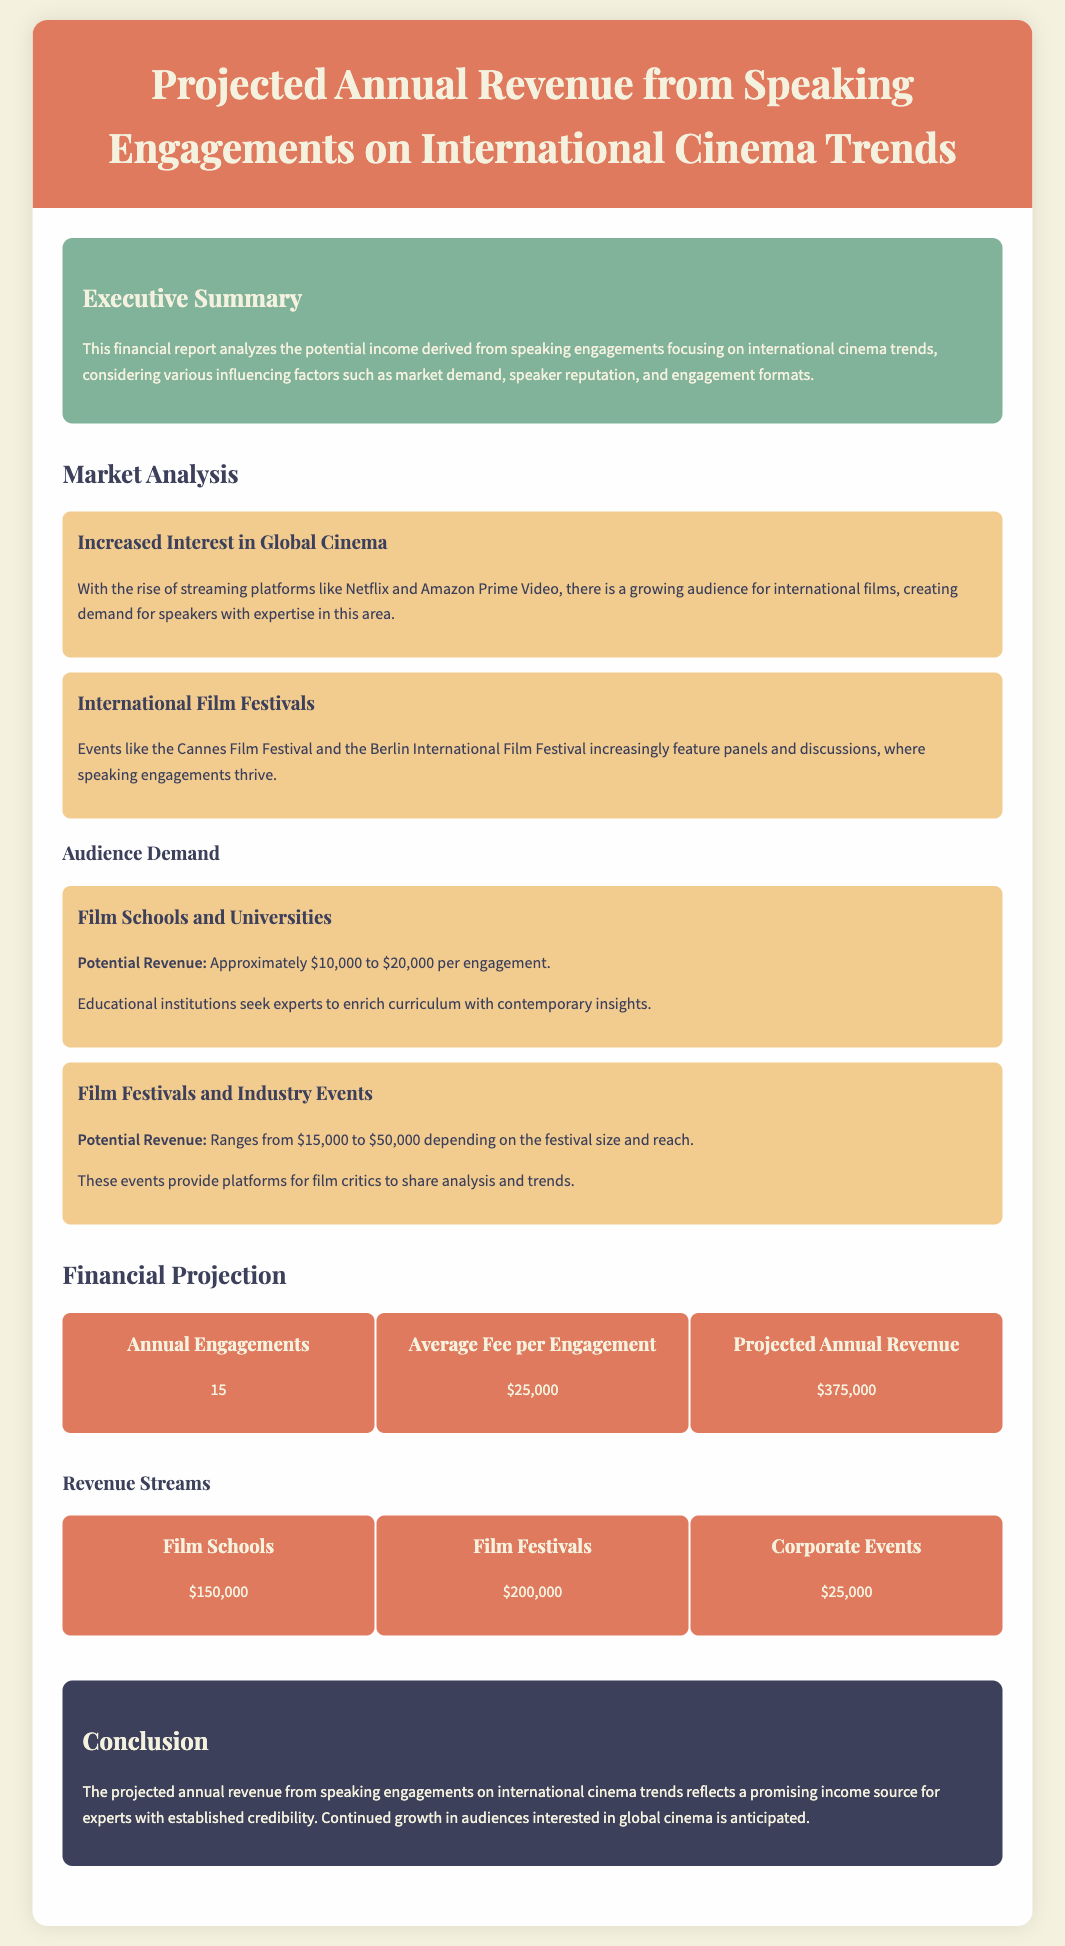what is the projected annual revenue? The projected annual revenue is stated in the financial projection section, which is calculated from the number of engagements and average fee per engagement.
Answer: $375,000 how many annual speaking engagements are projected? The document mentions the number of annual engagements in the financial projection section.
Answer: 15 what is the average fee per engagement? The average fee per engagement is mentioned in the financial projection section, providing an essential detail for revenue calculation.
Answer: $25,000 what is the potential revenue from film schools? The potential revenue from film schools is provided in the audience demand segment, detailing revenue per engagement type.
Answer: $150,000 which event type potentially generates the highest revenue? By comparing the revenue figures for different event types listed in the financial projection section, we find the event type with the highest revenue.
Answer: Film Festivals what is the total potential revenue from corporate events? The document includes specific financial data about corporate events under the revenue streams, allowing calculation of total revenue from that source.
Answer: $25,000 how does increased interest in global cinema impact speaking engagements? The document discusses the influence of market demand on the success of speaking engagements, highlighting increased audience interest.
Answer: Creates demand what are the anticipated sources for the projected annual revenue? The document outlines financial data from different sources, which together contribute to the overall projected revenue.
Answer: Film Schools, Film Festivals, Corporate Events what is the significance of international film festivals in this context? The document explains the role of international film festivals in fostering speaking engagement opportunities, underlining their importance in the industry.
Answer: Provide platforms 